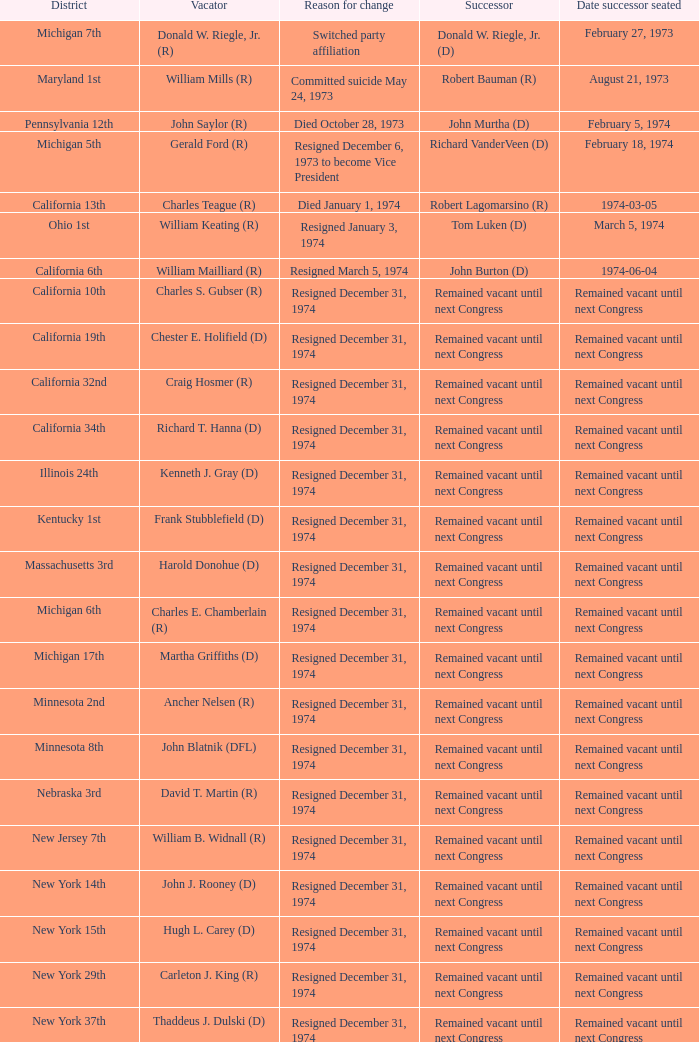Who was the vacator when the date successor seated was august 21, 1973? William Mills (R). 